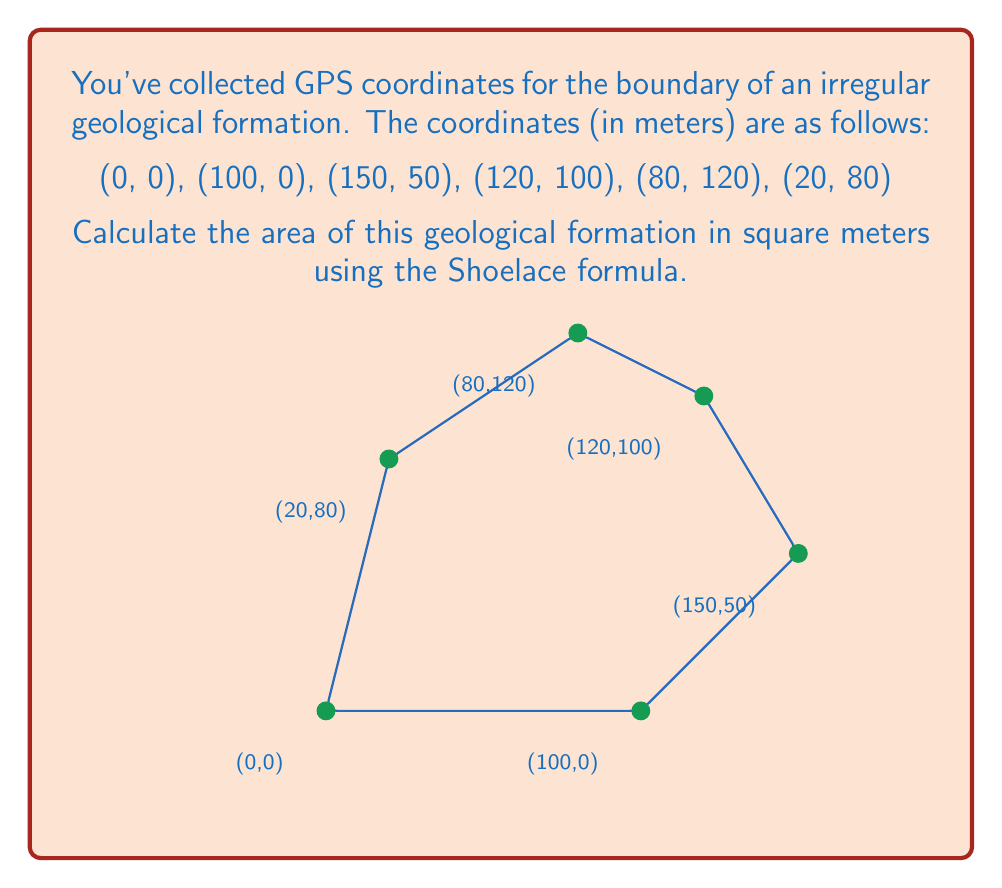Teach me how to tackle this problem. To calculate the area of an irregular polygon given its vertices, we can use the Shoelace formula (also known as the surveyor's formula). The formula is:

$$ A = \frac{1}{2}\left|\sum_{i=1}^{n-1} (x_i y_{i+1} - x_{i+1} y_i) + (x_n y_1 - x_1 y_n)\right| $$

Where $(x_i, y_i)$ are the coordinates of the $i$-th vertex.

Let's apply this formula step by step:

1) First, let's organize our data:
   $(x_1, y_1) = (0, 0)$
   $(x_2, y_2) = (100, 0)$
   $(x_3, y_3) = (150, 50)$
   $(x_4, y_4) = (120, 100)$
   $(x_5, y_5) = (80, 120)$
   $(x_6, y_6) = (20, 80)$

2) Now, let's calculate each term in the sum:
   $(x_1 y_2 - x_2 y_1) = 0 \cdot 0 - 100 \cdot 0 = 0$
   $(x_2 y_3 - x_3 y_2) = 100 \cdot 50 - 150 \cdot 0 = 5000$
   $(x_3 y_4 - x_4 y_3) = 150 \cdot 100 - 120 \cdot 50 = 9000$
   $(x_4 y_5 - x_5 y_4) = 120 \cdot 120 - 80 \cdot 100 = 6400$
   $(x_5 y_6 - x_6 y_5) = 80 \cdot 80 - 20 \cdot 120 = 4000$
   $(x_6 y_1 - x_1 y_6) = 20 \cdot 0 - 0 \cdot 80 = 0$

3) Sum all these terms:
   $0 + 5000 + 9000 + 6400 + 4000 + 0 = 24400$

4) Take the absolute value (which doesn't change anything in this case) and divide by 2:
   $\frac{1}{2} |24400| = 12200$

Therefore, the area of the geological formation is 12,200 square meters.
Answer: 12,200 m² 